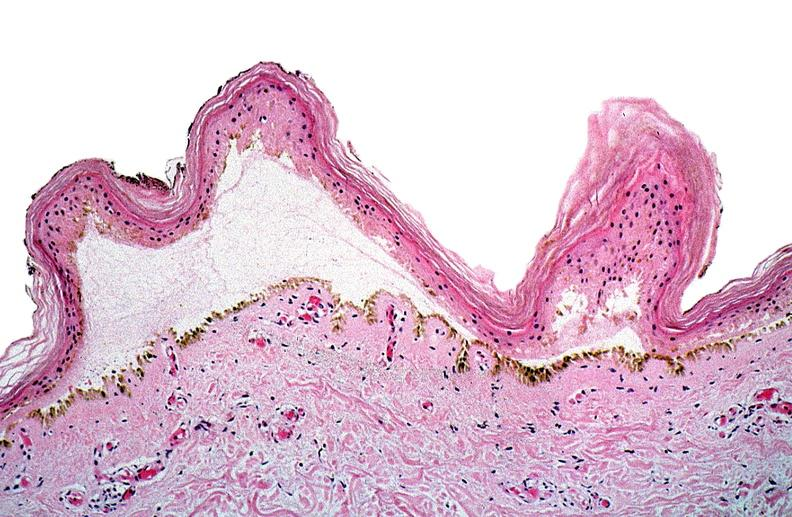what does this image show?
Answer the question using a single word or phrase. Thermal burned skin 